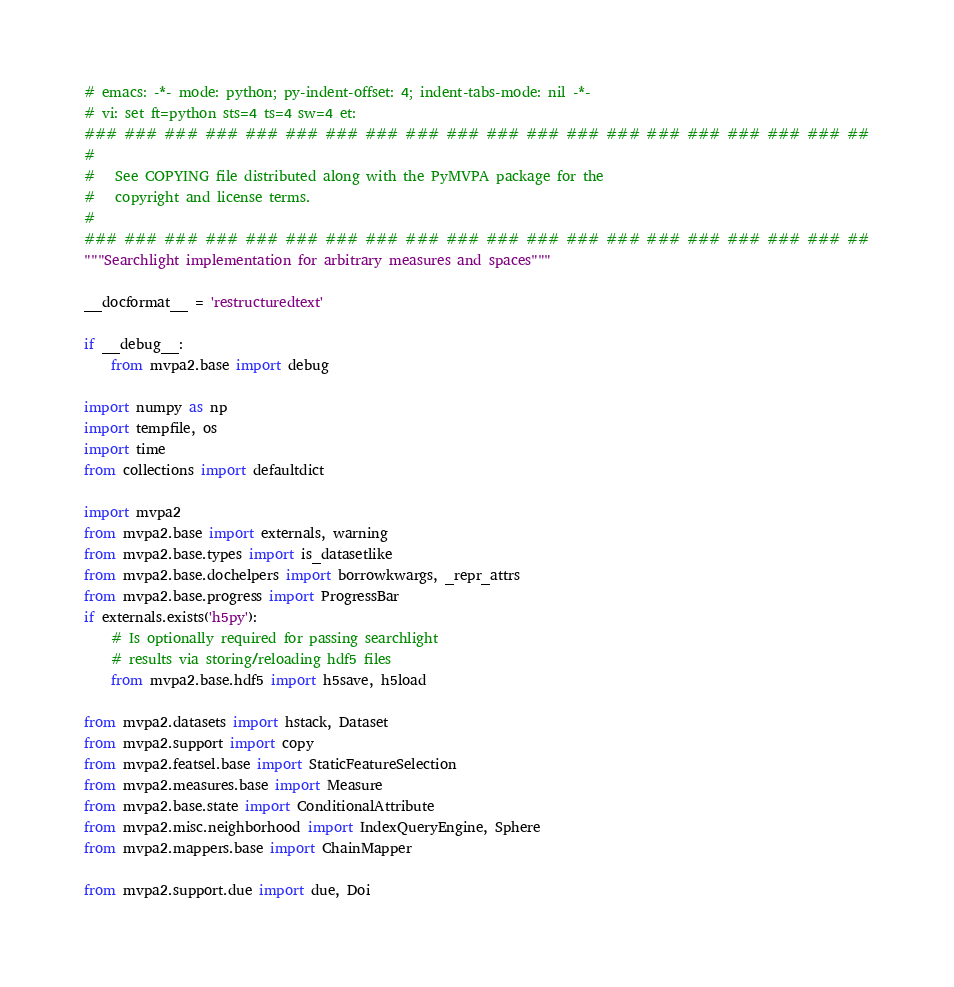Convert code to text. <code><loc_0><loc_0><loc_500><loc_500><_Python_># emacs: -*- mode: python; py-indent-offset: 4; indent-tabs-mode: nil -*-
# vi: set ft=python sts=4 ts=4 sw=4 et:
### ### ### ### ### ### ### ### ### ### ### ### ### ### ### ### ### ### ### ##
#
#   See COPYING file distributed along with the PyMVPA package for the
#   copyright and license terms.
#
### ### ### ### ### ### ### ### ### ### ### ### ### ### ### ### ### ### ### ##
"""Searchlight implementation for arbitrary measures and spaces"""

__docformat__ = 'restructuredtext'

if __debug__:
    from mvpa2.base import debug

import numpy as np
import tempfile, os
import time
from collections import defaultdict

import mvpa2
from mvpa2.base import externals, warning
from mvpa2.base.types import is_datasetlike
from mvpa2.base.dochelpers import borrowkwargs, _repr_attrs
from mvpa2.base.progress import ProgressBar
if externals.exists('h5py'):
    # Is optionally required for passing searchlight
    # results via storing/reloading hdf5 files
    from mvpa2.base.hdf5 import h5save, h5load

from mvpa2.datasets import hstack, Dataset
from mvpa2.support import copy
from mvpa2.featsel.base import StaticFeatureSelection
from mvpa2.measures.base import Measure
from mvpa2.base.state import ConditionalAttribute
from mvpa2.misc.neighborhood import IndexQueryEngine, Sphere
from mvpa2.mappers.base import ChainMapper

from mvpa2.support.due import due, Doi</code> 